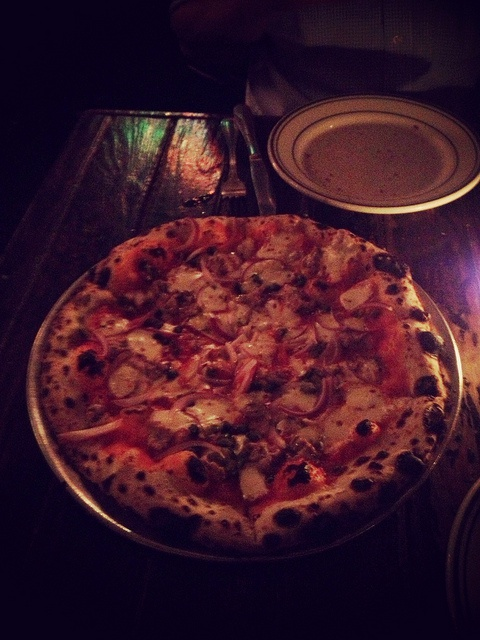Describe the objects in this image and their specific colors. I can see dining table in black, maroon, and brown tones, pizza in black, maroon, and brown tones, knife in black, purple, and gray tones, and fork in black, maroon, brown, and gray tones in this image. 